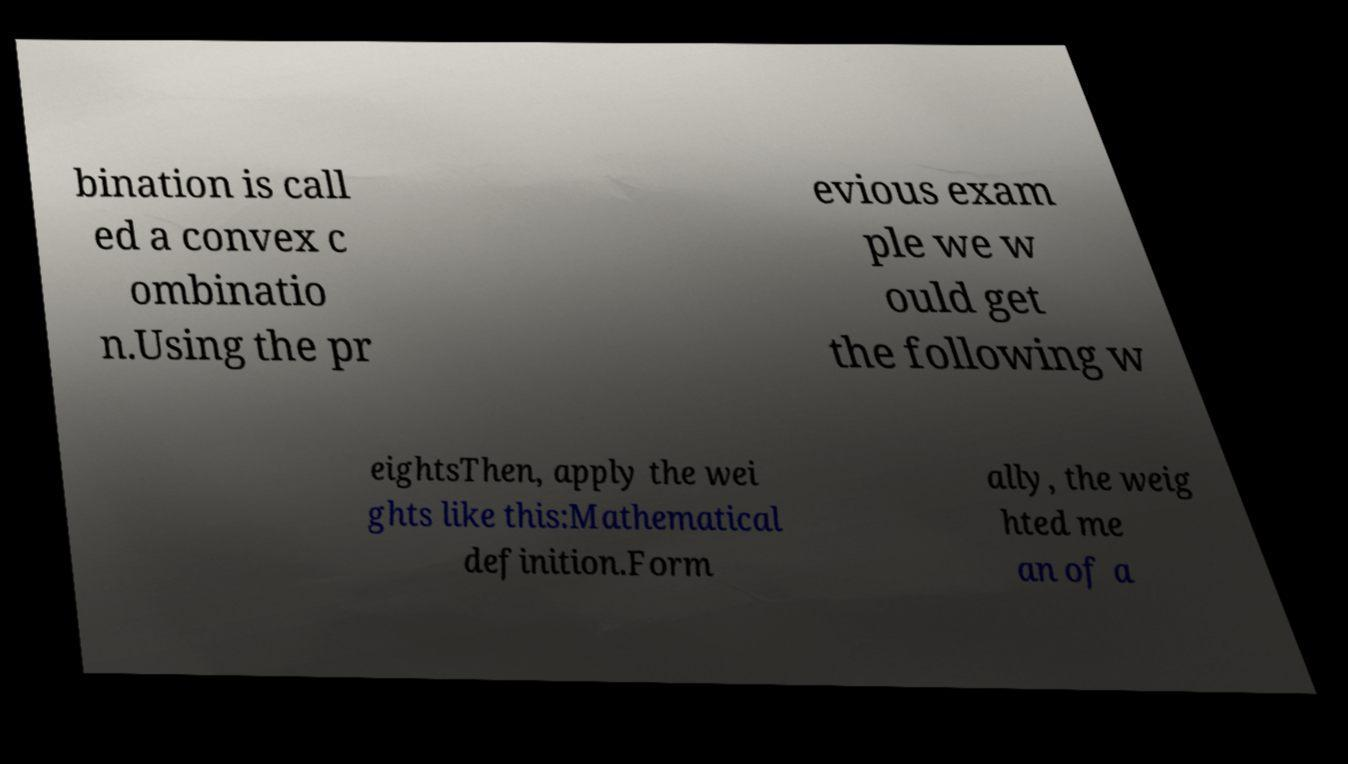Could you assist in decoding the text presented in this image and type it out clearly? bination is call ed a convex c ombinatio n.Using the pr evious exam ple we w ould get the following w eightsThen, apply the wei ghts like this:Mathematical definition.Form ally, the weig hted me an of a 